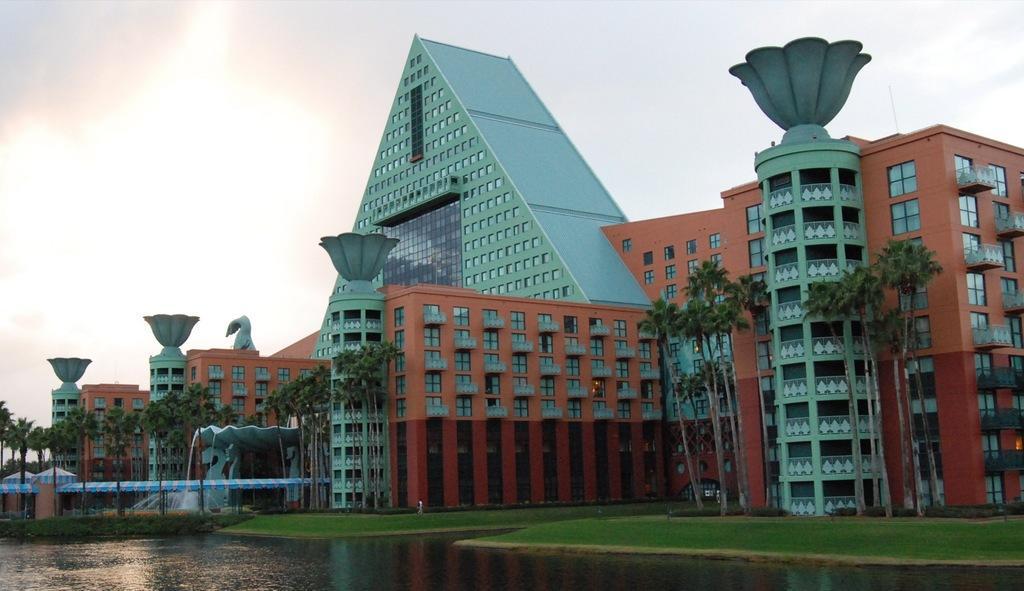Can you describe this image briefly? In the picture we can see water and near it, we can see a grass surface and on it we can see buildings with windows and near to the building we can see some trees and behind the building we can see a sky with clouds. 